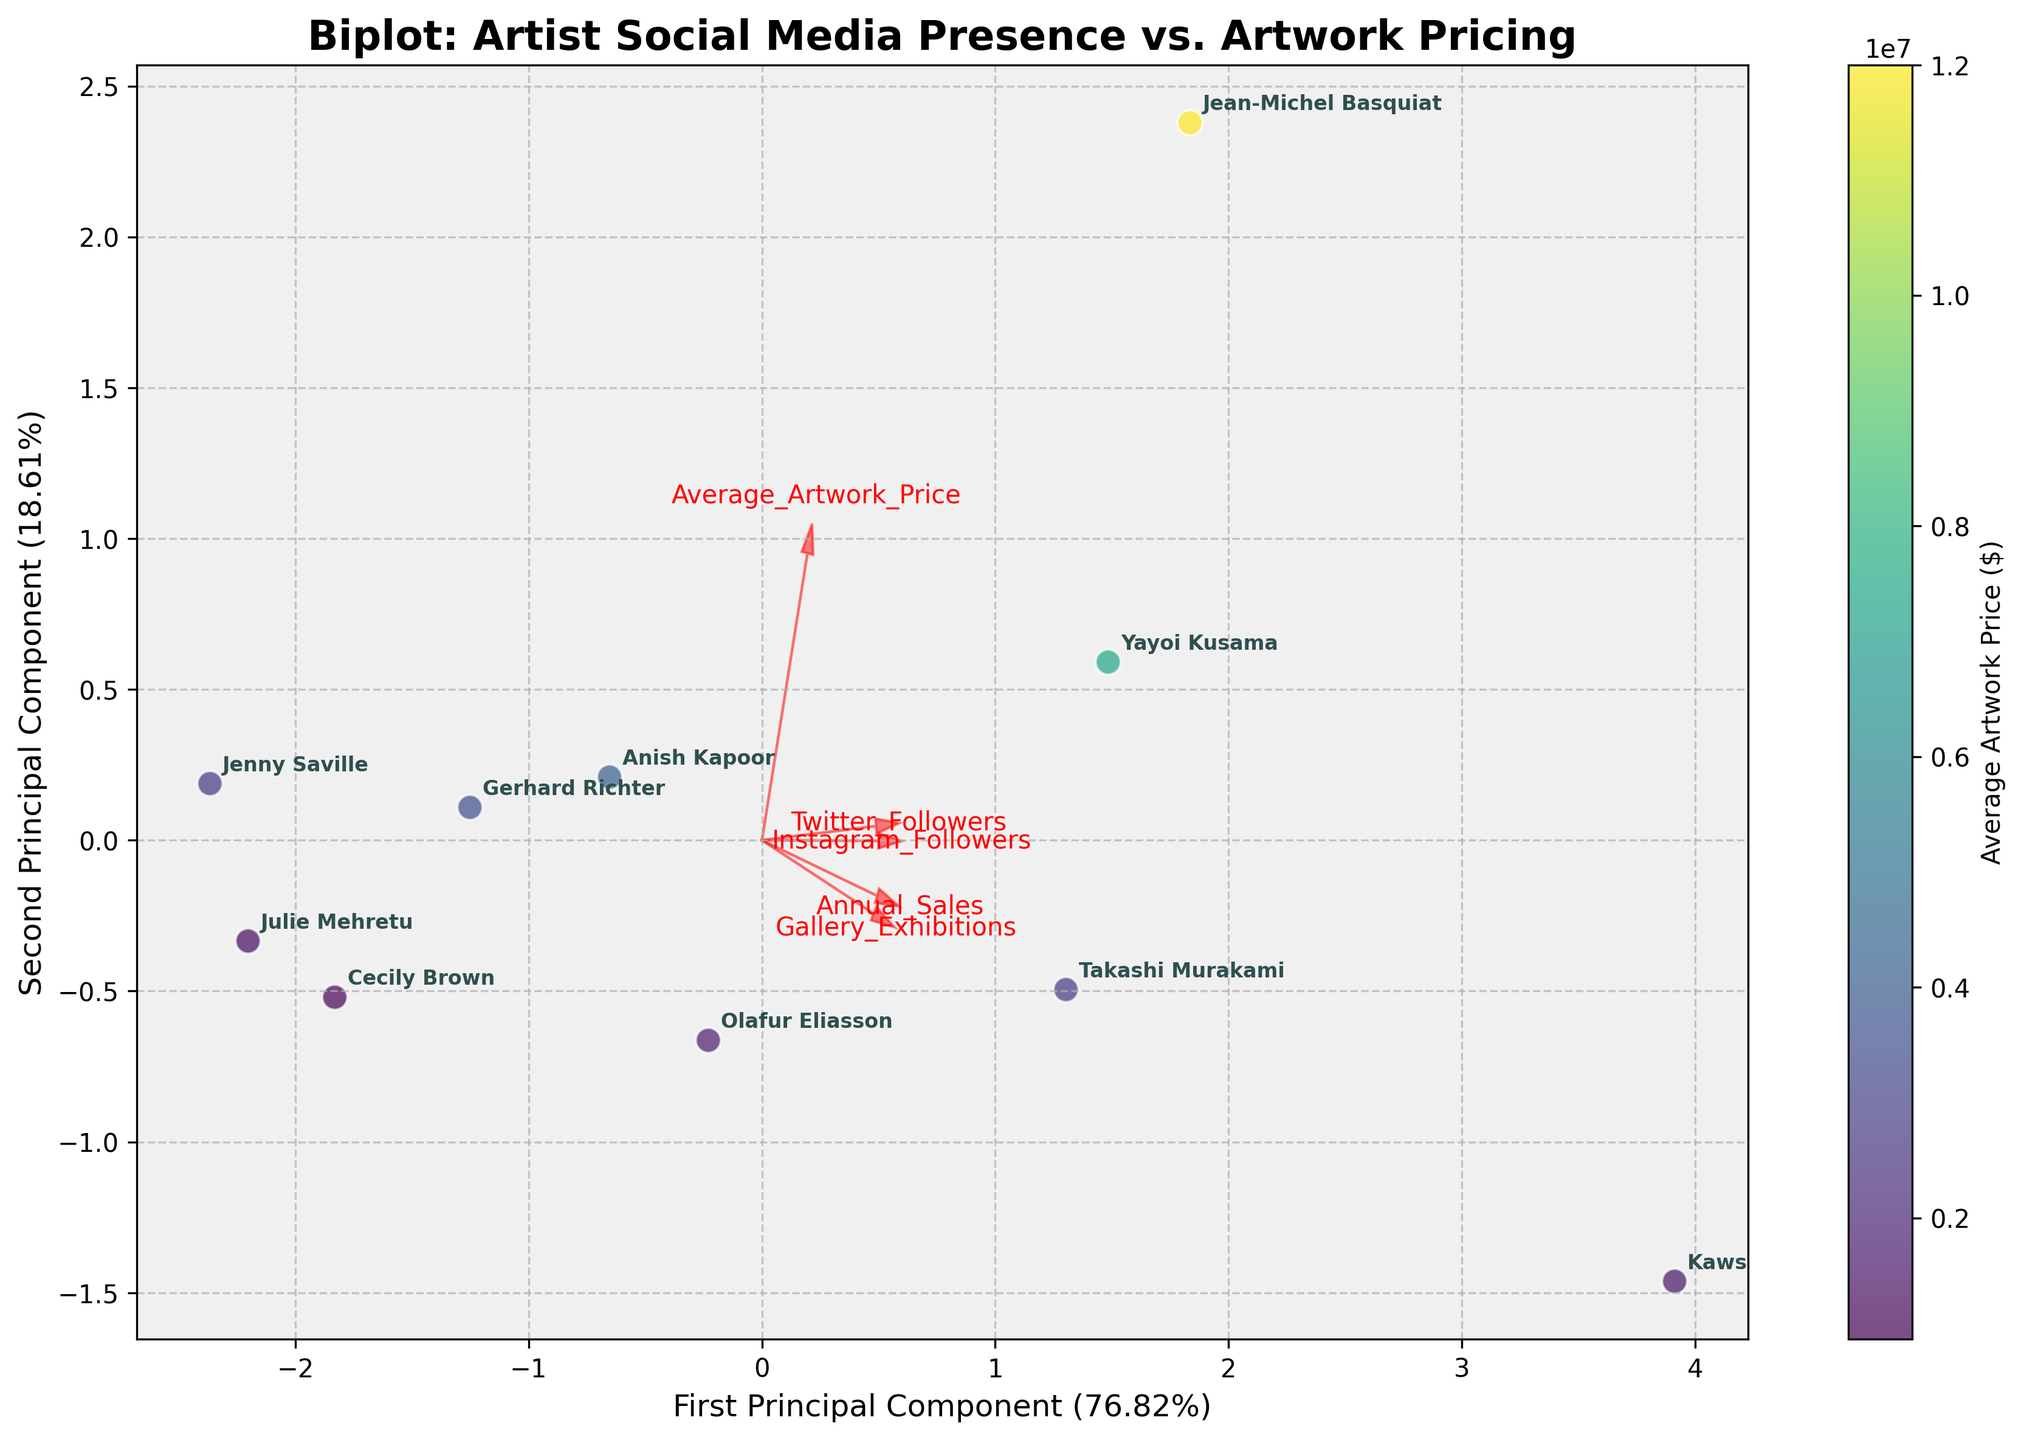Which artist has the most Instagram Followers? By looking at the annotations in the scatter plot, we can identify the artist whose point has the highest value along the axis representing Instagram Followers.
Answer: Kaws What feature shows the highest positive correlation with the first principal component? By examining the vectors emanating from the origin, we can determine which vector extends farthest along the direction of the first principal component.
Answer: Instagram_Followers How many notable correlations are highlighted by the vectors for the features? The number of red arrows in the biplot, which represent the feature vectors, indicate the number of notable correlations between the features and the principal components.
Answer: 5 Which artist has the highest Average Artwork Price, and where is this artist located in the plot? From the annotations and the color intensity on the scatter plot, we can identify Jean-Michel Basquiat as the artist with the highest Average Artwork Price. His position on the plot can be found by locating the text label "Jean-Michel Basquiat."
Answer: Jean-Michel Basquiat, upper right Compare Cecily Brown and Julie Mehretu. Who has higher Annual Sales and how do their Twitter Followers compare? By observing the locations of Cecily Brown and Julie Mehretu in the scatter plot, and considering the features indicated by the principal components, we can infer their relative positions in Twitter Followers and Annual Sales. Cecily Brown has higher Annual Sales, but Julie Mehretu has fewer Twitter Followers.
Answer: Cecily Brown has higher Annual Sales; Julie Mehretu has fewer Twitter Followers Which two features are almost perpendicular to each other and show very little correlation? By examining the angles between the red arrows (feature vectors), we can identify two features whose vectors are almost perpendicular, indicating very little correlation.
Answer: Gallery_Exhibitions and Average_Artwork_Price Is there any feature that shows a negative contribution to the first principal component? If yes, which one? By looking at the direction of the feature vectors relative to the principal components, we can check if any of them point in an opposite direction (negative contribution) along the first principal component.
Answer: No, there is no feature with a negative contribution Which artist is closest to the origin, and what does it imply about their feature values? By identifying the data point and artist name nearest to the origin in the plot, we can infer that this artist has average values for the features being analyzed.
Answer: Jenny Saville How much of the total variance in the dataset does the first principal component explain? By referring to the axis label for the first principal component, we can extract the explained variance percentage.
Answer: 61.68% What do the arrows (feature vectors) indicate about the relationship between social media presence and Average Artwork Price? By examining the directions and lengths of the arrows for social media presence (Instagram_Followers, Twitter_Followers) and Average_Artwork_Price, we can interpret the relationship between these features. Longer arrows in the same direction suggest a strong positive correlation.
Answer: Strong positive correlation between social media presence and Average_Artwork_Price 